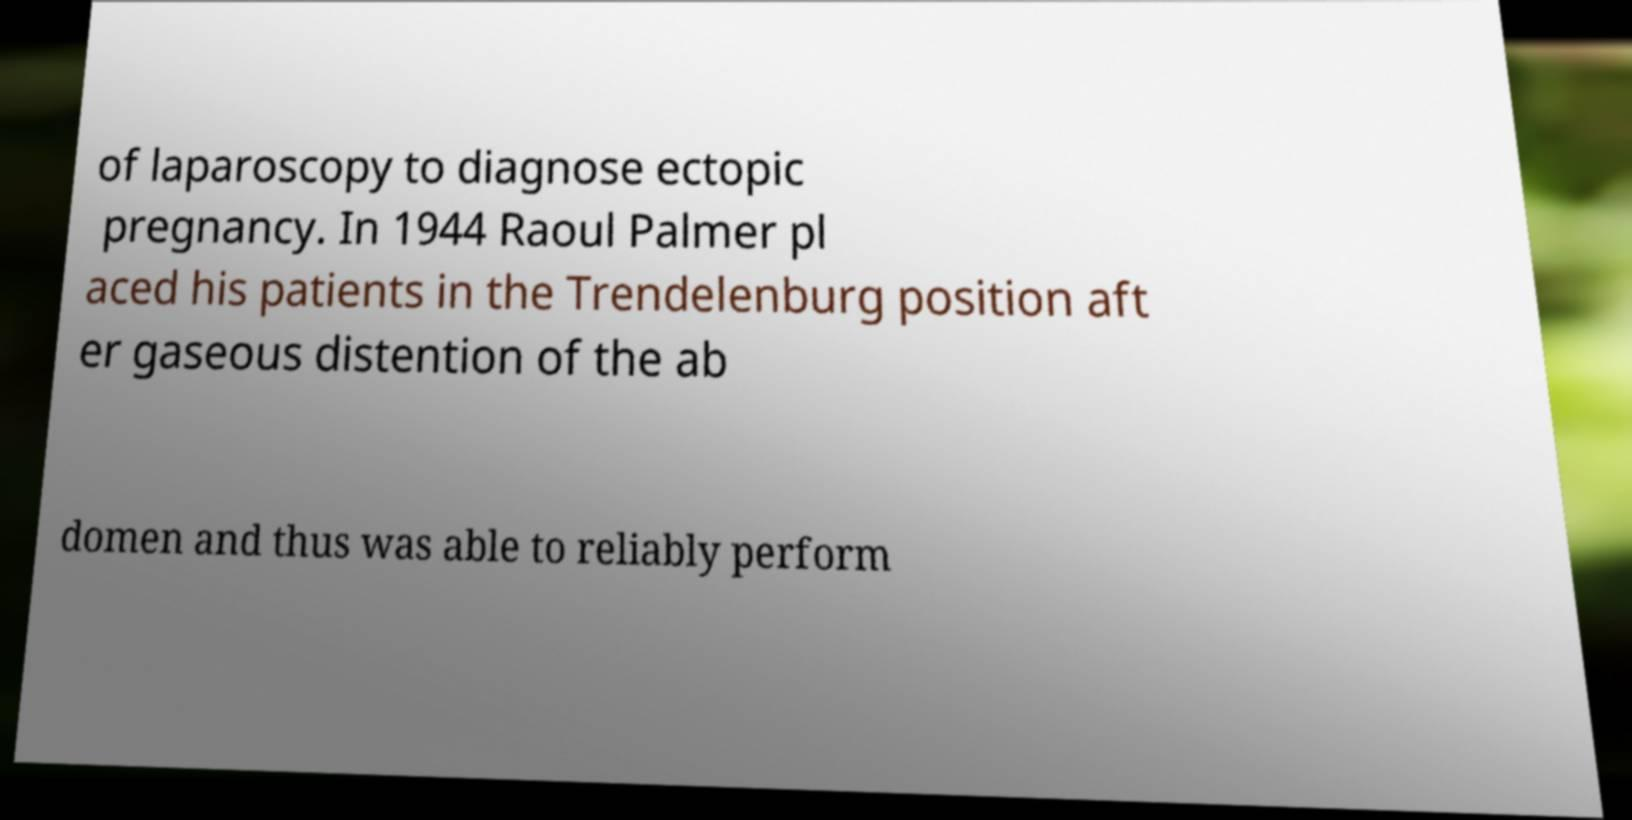For documentation purposes, I need the text within this image transcribed. Could you provide that? of laparoscopy to diagnose ectopic pregnancy. In 1944 Raoul Palmer pl aced his patients in the Trendelenburg position aft er gaseous distention of the ab domen and thus was able to reliably perform 